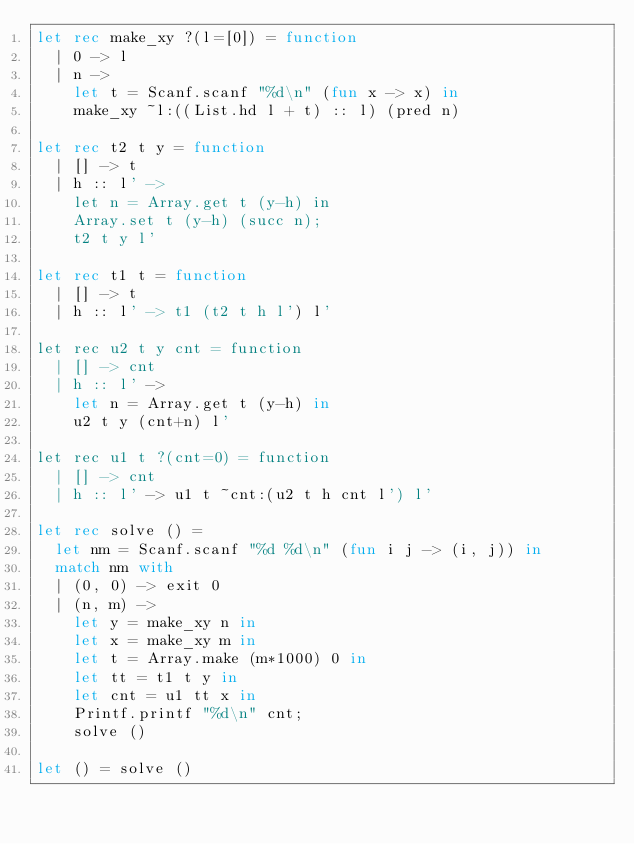Convert code to text. <code><loc_0><loc_0><loc_500><loc_500><_OCaml_>let rec make_xy ?(l=[0]) = function
  | 0 -> l
  | n ->
    let t = Scanf.scanf "%d\n" (fun x -> x) in
    make_xy ~l:((List.hd l + t) :: l) (pred n)

let rec t2 t y = function
  | [] -> t
  | h :: l' ->
    let n = Array.get t (y-h) in
    Array.set t (y-h) (succ n);
    t2 t y l'

let rec t1 t = function
  | [] -> t
  | h :: l' -> t1 (t2 t h l') l'

let rec u2 t y cnt = function
  | [] -> cnt
  | h :: l' ->
    let n = Array.get t (y-h) in
    u2 t y (cnt+n) l'

let rec u1 t ?(cnt=0) = function
  | [] -> cnt
  | h :: l' -> u1 t ~cnt:(u2 t h cnt l') l'

let rec solve () =
  let nm = Scanf.scanf "%d %d\n" (fun i j -> (i, j)) in
  match nm with
  | (0, 0) -> exit 0
  | (n, m) ->
    let y = make_xy n in
    let x = make_xy m in
    let t = Array.make (m*1000) 0 in
    let tt = t1 t y in
    let cnt = u1 tt x in
    Printf.printf "%d\n" cnt;
    solve ()

let () = solve ()</code> 